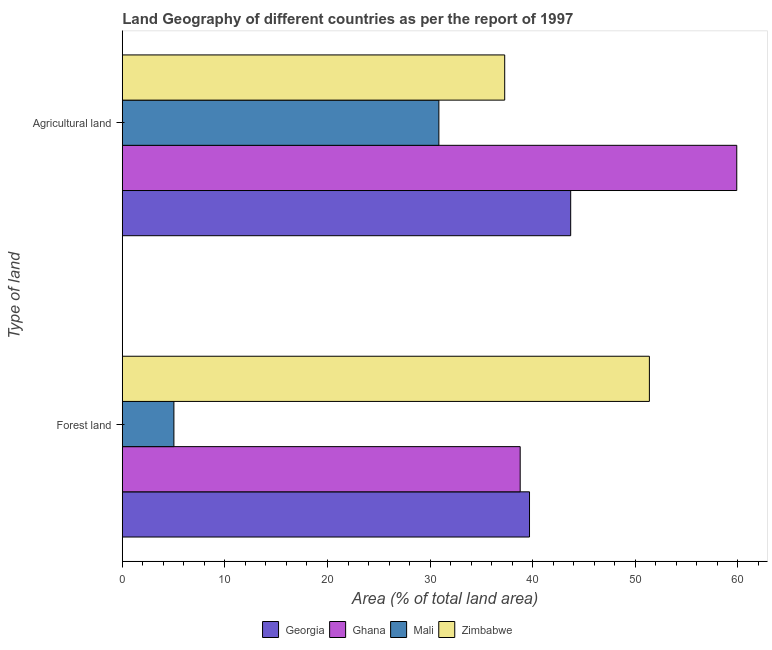How many groups of bars are there?
Ensure brevity in your answer.  2. Are the number of bars per tick equal to the number of legend labels?
Keep it short and to the point. Yes. How many bars are there on the 2nd tick from the bottom?
Offer a terse response. 4. What is the label of the 1st group of bars from the top?
Give a very brief answer. Agricultural land. What is the percentage of land area under forests in Ghana?
Provide a short and direct response. 38.78. Across all countries, what is the maximum percentage of land area under agriculture?
Give a very brief answer. 59.89. Across all countries, what is the minimum percentage of land area under agriculture?
Your answer should be compact. 30.86. In which country was the percentage of land area under forests maximum?
Your answer should be very brief. Zimbabwe. In which country was the percentage of land area under agriculture minimum?
Your answer should be compact. Mali. What is the total percentage of land area under agriculture in the graph?
Your answer should be very brief. 171.73. What is the difference between the percentage of land area under forests in Zimbabwe and that in Georgia?
Make the answer very short. 11.69. What is the difference between the percentage of land area under agriculture in Mali and the percentage of land area under forests in Zimbabwe?
Make the answer very short. -20.52. What is the average percentage of land area under agriculture per country?
Keep it short and to the point. 42.93. What is the difference between the percentage of land area under forests and percentage of land area under agriculture in Zimbabwe?
Ensure brevity in your answer.  14.1. In how many countries, is the percentage of land area under forests greater than 16 %?
Your response must be concise. 3. What is the ratio of the percentage of land area under forests in Ghana to that in Zimbabwe?
Your answer should be compact. 0.75. What does the 1st bar from the top in Forest land represents?
Offer a terse response. Zimbabwe. What does the 2nd bar from the bottom in Agricultural land represents?
Give a very brief answer. Ghana. How many bars are there?
Ensure brevity in your answer.  8. Are all the bars in the graph horizontal?
Provide a succinct answer. Yes. Does the graph contain grids?
Keep it short and to the point. No. What is the title of the graph?
Give a very brief answer. Land Geography of different countries as per the report of 1997. Does "Mexico" appear as one of the legend labels in the graph?
Make the answer very short. No. What is the label or title of the X-axis?
Provide a succinct answer. Area (% of total land area). What is the label or title of the Y-axis?
Your answer should be compact. Type of land. What is the Area (% of total land area) in Georgia in Forest land?
Offer a very short reply. 39.69. What is the Area (% of total land area) of Ghana in Forest land?
Provide a short and direct response. 38.78. What is the Area (% of total land area) of Mali in Forest land?
Provide a succinct answer. 5.03. What is the Area (% of total land area) of Zimbabwe in Forest land?
Provide a succinct answer. 51.38. What is the Area (% of total land area) of Georgia in Agricultural land?
Give a very brief answer. 43.7. What is the Area (% of total land area) of Ghana in Agricultural land?
Make the answer very short. 59.89. What is the Area (% of total land area) of Mali in Agricultural land?
Your answer should be very brief. 30.86. What is the Area (% of total land area) in Zimbabwe in Agricultural land?
Ensure brevity in your answer.  37.27. Across all Type of land, what is the maximum Area (% of total land area) in Georgia?
Offer a terse response. 43.7. Across all Type of land, what is the maximum Area (% of total land area) in Ghana?
Provide a short and direct response. 59.89. Across all Type of land, what is the maximum Area (% of total land area) of Mali?
Provide a succinct answer. 30.86. Across all Type of land, what is the maximum Area (% of total land area) of Zimbabwe?
Offer a terse response. 51.38. Across all Type of land, what is the minimum Area (% of total land area) in Georgia?
Your answer should be very brief. 39.69. Across all Type of land, what is the minimum Area (% of total land area) in Ghana?
Make the answer very short. 38.78. Across all Type of land, what is the minimum Area (% of total land area) of Mali?
Give a very brief answer. 5.03. Across all Type of land, what is the minimum Area (% of total land area) of Zimbabwe?
Keep it short and to the point. 37.27. What is the total Area (% of total land area) in Georgia in the graph?
Ensure brevity in your answer.  83.39. What is the total Area (% of total land area) of Ghana in the graph?
Your answer should be very brief. 98.67. What is the total Area (% of total land area) in Mali in the graph?
Make the answer very short. 35.89. What is the total Area (% of total land area) in Zimbabwe in the graph?
Make the answer very short. 88.65. What is the difference between the Area (% of total land area) in Georgia in Forest land and that in Agricultural land?
Your answer should be very brief. -4.01. What is the difference between the Area (% of total land area) in Ghana in Forest land and that in Agricultural land?
Offer a very short reply. -21.11. What is the difference between the Area (% of total land area) in Mali in Forest land and that in Agricultural land?
Your answer should be compact. -25.83. What is the difference between the Area (% of total land area) in Zimbabwe in Forest land and that in Agricultural land?
Your answer should be very brief. 14.1. What is the difference between the Area (% of total land area) of Georgia in Forest land and the Area (% of total land area) of Ghana in Agricultural land?
Offer a very short reply. -20.2. What is the difference between the Area (% of total land area) in Georgia in Forest land and the Area (% of total land area) in Mali in Agricultural land?
Provide a short and direct response. 8.83. What is the difference between the Area (% of total land area) in Georgia in Forest land and the Area (% of total land area) in Zimbabwe in Agricultural land?
Provide a succinct answer. 2.42. What is the difference between the Area (% of total land area) of Ghana in Forest land and the Area (% of total land area) of Mali in Agricultural land?
Give a very brief answer. 7.93. What is the difference between the Area (% of total land area) in Ghana in Forest land and the Area (% of total land area) in Zimbabwe in Agricultural land?
Your answer should be compact. 1.51. What is the difference between the Area (% of total land area) in Mali in Forest land and the Area (% of total land area) in Zimbabwe in Agricultural land?
Give a very brief answer. -32.24. What is the average Area (% of total land area) of Georgia per Type of land?
Provide a succinct answer. 41.7. What is the average Area (% of total land area) in Ghana per Type of land?
Provide a succinct answer. 49.34. What is the average Area (% of total land area) in Mali per Type of land?
Give a very brief answer. 17.94. What is the average Area (% of total land area) in Zimbabwe per Type of land?
Give a very brief answer. 44.32. What is the difference between the Area (% of total land area) in Georgia and Area (% of total land area) in Ghana in Forest land?
Your answer should be compact. 0.91. What is the difference between the Area (% of total land area) of Georgia and Area (% of total land area) of Mali in Forest land?
Make the answer very short. 34.66. What is the difference between the Area (% of total land area) of Georgia and Area (% of total land area) of Zimbabwe in Forest land?
Make the answer very short. -11.69. What is the difference between the Area (% of total land area) in Ghana and Area (% of total land area) in Mali in Forest land?
Give a very brief answer. 33.75. What is the difference between the Area (% of total land area) in Ghana and Area (% of total land area) in Zimbabwe in Forest land?
Provide a short and direct response. -12.59. What is the difference between the Area (% of total land area) of Mali and Area (% of total land area) of Zimbabwe in Forest land?
Provide a succinct answer. -46.35. What is the difference between the Area (% of total land area) of Georgia and Area (% of total land area) of Ghana in Agricultural land?
Your answer should be very brief. -16.19. What is the difference between the Area (% of total land area) of Georgia and Area (% of total land area) of Mali in Agricultural land?
Offer a very short reply. 12.85. What is the difference between the Area (% of total land area) in Georgia and Area (% of total land area) in Zimbabwe in Agricultural land?
Provide a succinct answer. 6.43. What is the difference between the Area (% of total land area) of Ghana and Area (% of total land area) of Mali in Agricultural land?
Offer a very short reply. 29.04. What is the difference between the Area (% of total land area) of Ghana and Area (% of total land area) of Zimbabwe in Agricultural land?
Offer a very short reply. 22.62. What is the difference between the Area (% of total land area) in Mali and Area (% of total land area) in Zimbabwe in Agricultural land?
Make the answer very short. -6.42. What is the ratio of the Area (% of total land area) of Georgia in Forest land to that in Agricultural land?
Provide a short and direct response. 0.91. What is the ratio of the Area (% of total land area) of Ghana in Forest land to that in Agricultural land?
Provide a succinct answer. 0.65. What is the ratio of the Area (% of total land area) in Mali in Forest land to that in Agricultural land?
Make the answer very short. 0.16. What is the ratio of the Area (% of total land area) in Zimbabwe in Forest land to that in Agricultural land?
Offer a very short reply. 1.38. What is the difference between the highest and the second highest Area (% of total land area) of Georgia?
Provide a short and direct response. 4.01. What is the difference between the highest and the second highest Area (% of total land area) in Ghana?
Give a very brief answer. 21.11. What is the difference between the highest and the second highest Area (% of total land area) in Mali?
Your answer should be compact. 25.83. What is the difference between the highest and the second highest Area (% of total land area) in Zimbabwe?
Make the answer very short. 14.1. What is the difference between the highest and the lowest Area (% of total land area) in Georgia?
Provide a short and direct response. 4.01. What is the difference between the highest and the lowest Area (% of total land area) of Ghana?
Your answer should be very brief. 21.11. What is the difference between the highest and the lowest Area (% of total land area) of Mali?
Offer a terse response. 25.83. What is the difference between the highest and the lowest Area (% of total land area) of Zimbabwe?
Give a very brief answer. 14.1. 